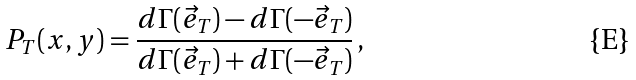Convert formula to latex. <formula><loc_0><loc_0><loc_500><loc_500>P _ { T } ( x , y ) = \frac { d \Gamma ( \vec { e } _ { T } ) - d \Gamma ( - \vec { e } _ { T } ) } { d \Gamma ( \vec { e } _ { T } ) + d \Gamma ( - \vec { e } _ { T } ) } \, ,</formula> 